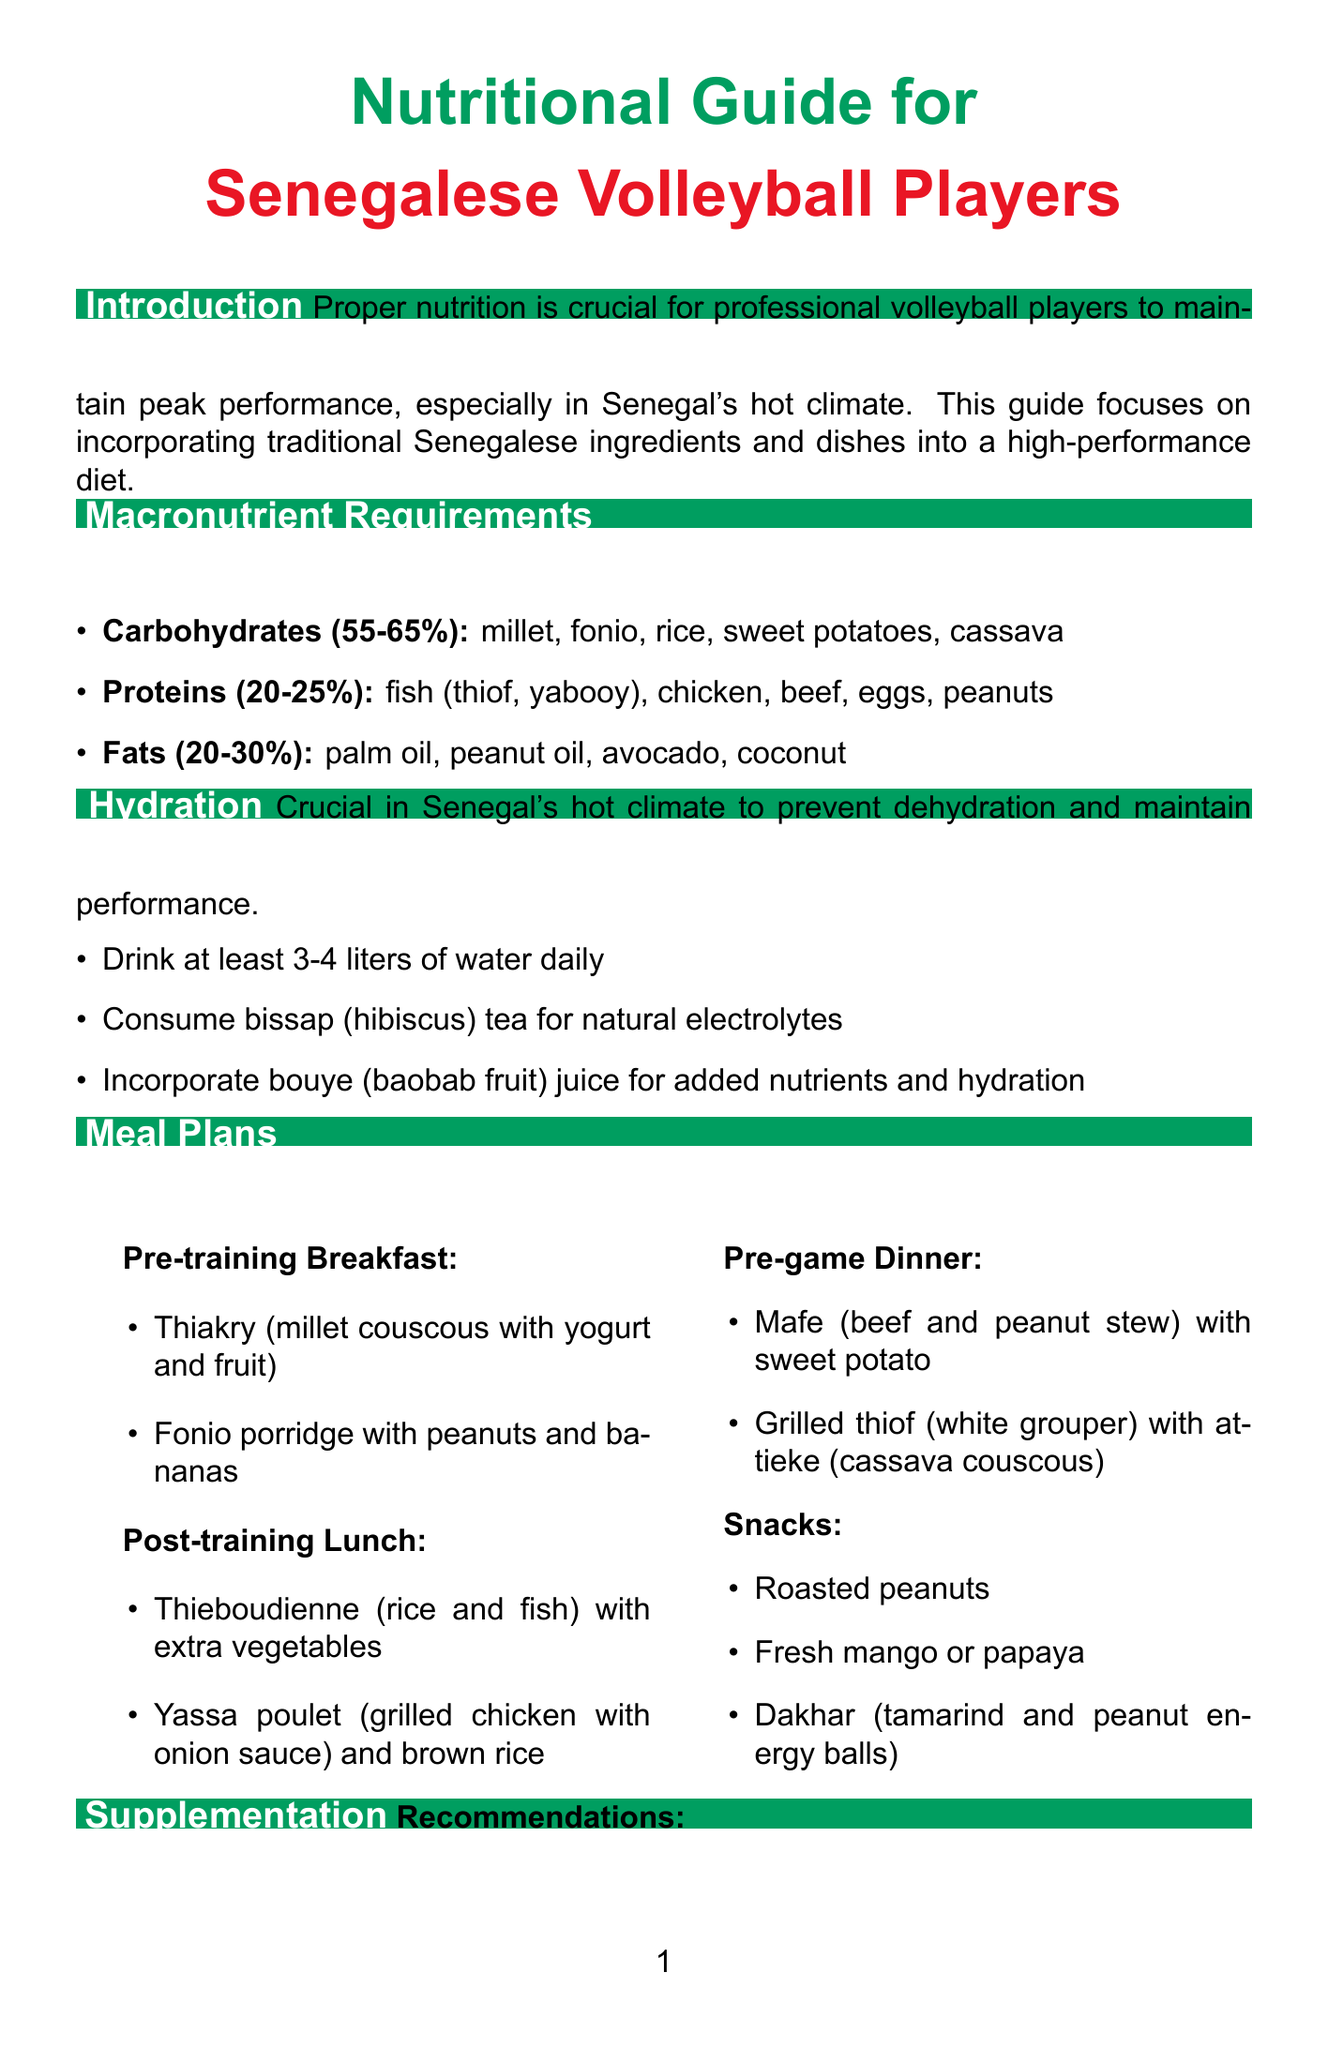what is the title of the document? The title is stated at the top of the document, which refers to a nutritional guide for a specific group.
Answer: Nutritional Guide for Senegalese Volleyball Players what percentage of the diet should come from carbohydrates? The document specifies the percentage of total calorie intake that should come from carbohydrates.
Answer: 55-65% name one source of protein recommended in the guide. The document provides a list of protein sources that athletes should include in their diet.
Answer: fish (thiof, yabooy) how many liters of water should athletes drink daily? The hydration section indicates the daily water intake recommendation for athletes in Senegal's climate.
Answer: 3-4 liters what is a recommended pre-game dinner option? The meal plan section lists specific dinner options recommended for athletes before games.
Answer: Mafe (beef and peanut stew) with sweet potato what should athletes focus on during Ramadan? The special considerations section addresses dietary focus for athletes during the fasting month.
Answer: Nutrient-dense foods how can athletes recover after games according to the guide? The recovery nutrition section provides options for meals and drinks to aid recovery after training or games.
Answer: Domoda (peanut and tomato stew) with rice and grilled fish which local superfood is high in protein and vitamins? The local superfoods section highlights several regional foods, identifying those with specific health benefits.
Answer: Moringa what is one benefit of baobab mentioned in the document? The local superfoods section outlines the benefits of baobab as part of the diet for athletes.
Answer: Rich in vitamin C and fiber 